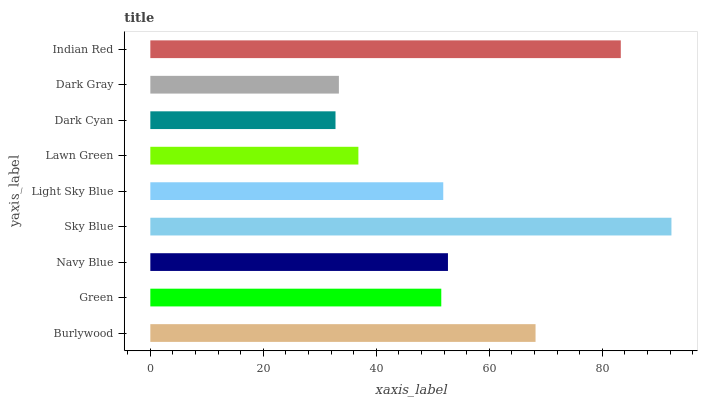Is Dark Cyan the minimum?
Answer yes or no. Yes. Is Sky Blue the maximum?
Answer yes or no. Yes. Is Green the minimum?
Answer yes or no. No. Is Green the maximum?
Answer yes or no. No. Is Burlywood greater than Green?
Answer yes or no. Yes. Is Green less than Burlywood?
Answer yes or no. Yes. Is Green greater than Burlywood?
Answer yes or no. No. Is Burlywood less than Green?
Answer yes or no. No. Is Light Sky Blue the high median?
Answer yes or no. Yes. Is Light Sky Blue the low median?
Answer yes or no. Yes. Is Lawn Green the high median?
Answer yes or no. No. Is Dark Cyan the low median?
Answer yes or no. No. 